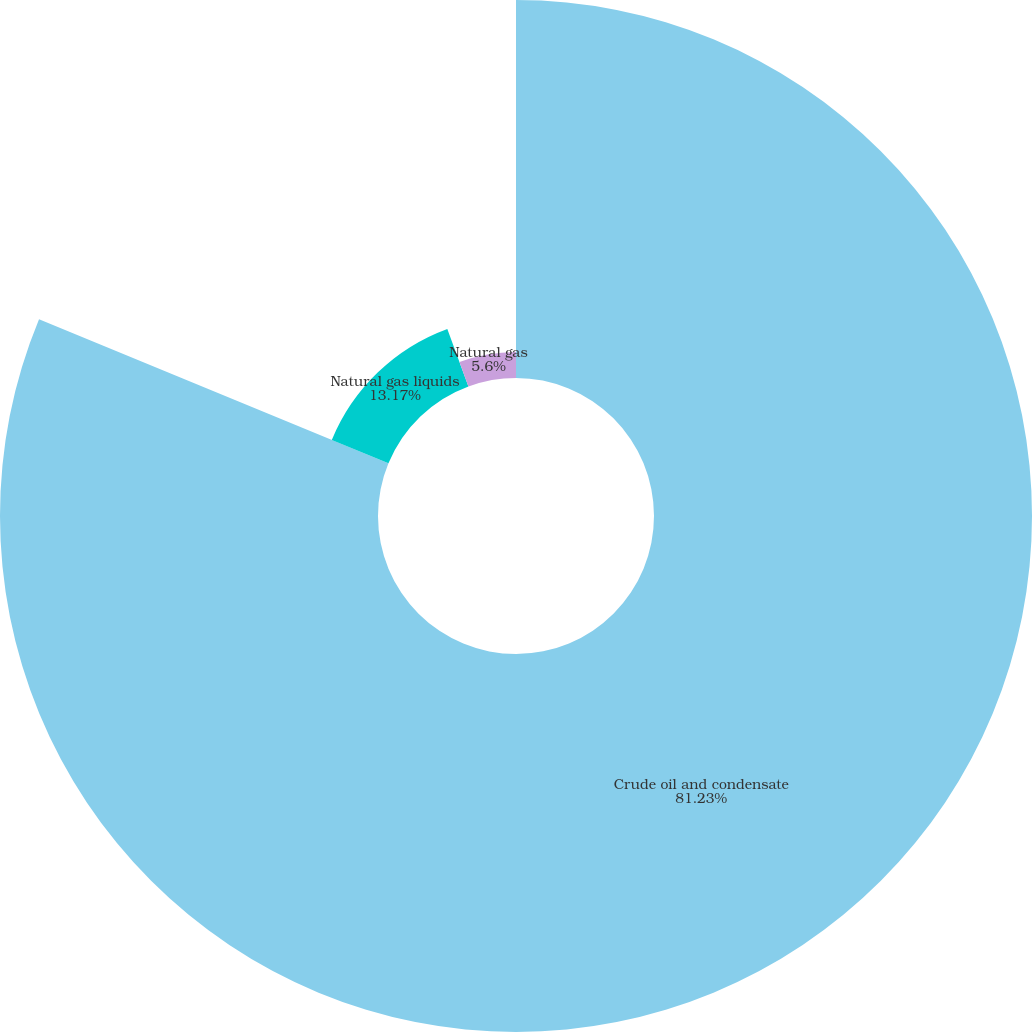<chart> <loc_0><loc_0><loc_500><loc_500><pie_chart><fcel>Crude oil and condensate<fcel>Natural gas liquids<fcel>Natural gas<nl><fcel>81.23%<fcel>13.17%<fcel>5.6%<nl></chart> 